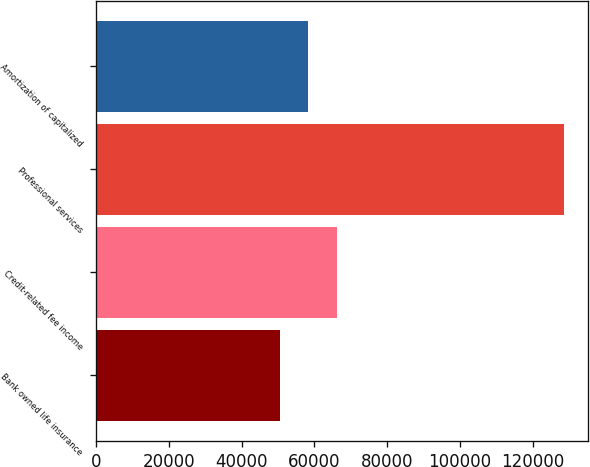Convert chart to OTSL. <chart><loc_0><loc_0><loc_500><loc_500><bar_chart><fcel>Bank owned life insurance<fcel>Credit-related fee income<fcel>Professional services<fcel>Amortization of capitalized<nl><fcel>50483<fcel>66112.2<fcel>128629<fcel>58297.6<nl></chart> 